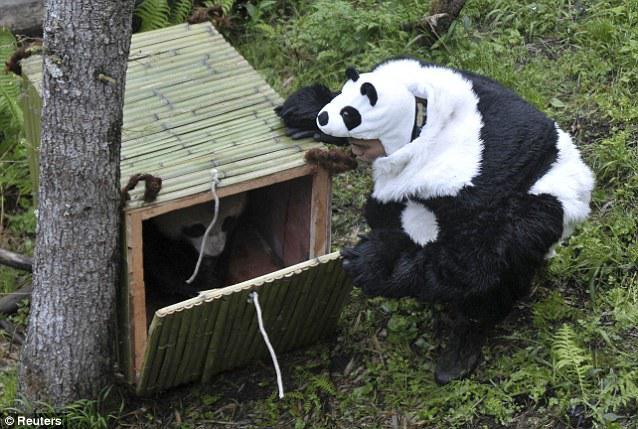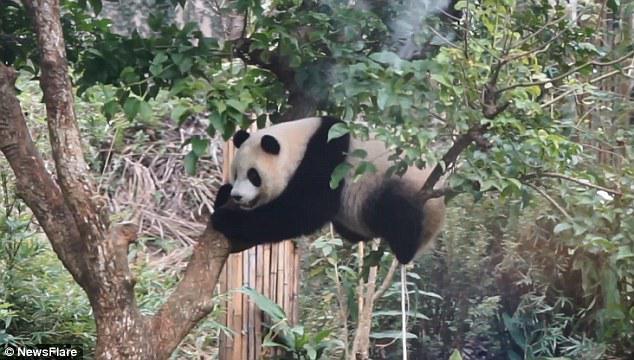The first image is the image on the left, the second image is the image on the right. Assess this claim about the two images: "A total of two pandas are off the ground and hanging to tree limbs.". Correct or not? Answer yes or no. No. The first image is the image on the left, the second image is the image on the right. Evaluate the accuracy of this statement regarding the images: "One panda is sitting on a branch in the right image.". Is it true? Answer yes or no. Yes. 